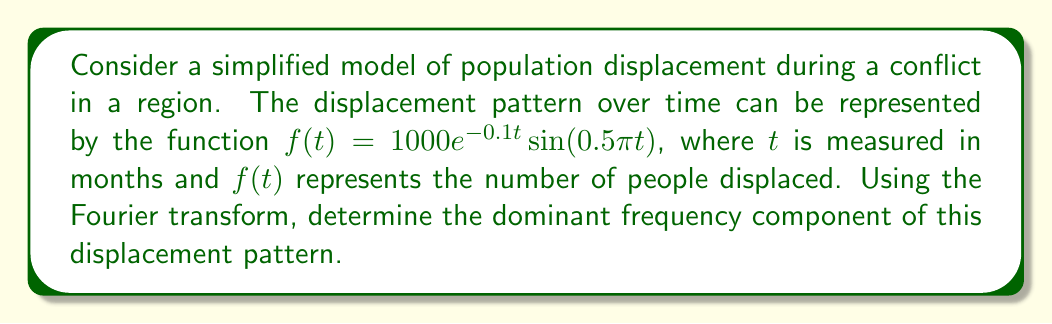What is the answer to this math problem? To solve this problem, we'll follow these steps:

1) The Fourier transform of $f(t)$ is given by:

   $$F(\omega) = \int_{-\infty}^{\infty} f(t)e^{-i\omega t}dt$$

2) In our case, $f(t) = 1000e^{-0.1t}\sin(0.5\pi t)$

3) The Fourier transform of a damped sinusoid $e^{-at}\sin(bt)$ is:

   $$\frac{b}{(a+i\omega)^2 + b^2}$$

4) In our function, $a = 0.1$ and $b = 0.5\pi$. The amplitude (1000) is a scaling factor.

5) Therefore, the Fourier transform of our function is:

   $$F(\omega) = 1000 \cdot \frac{0.5\pi}{(0.1+i\omega)^2 + (0.5\pi)^2}$$

6) To find the dominant frequency, we need to find the maximum of $|F(\omega)|$:

   $$|F(\omega)| = \frac{500\pi}{\sqrt{(0.01-\omega^2+0.25\pi^2)^2 + 0.04\omega^2}}$$

7) The maximum of this function occurs when $\omega = 0.5\pi$

8) Converting from angular frequency to regular frequency:

   $$f = \frac{\omega}{2\pi} = \frac{0.5\pi}{2\pi} = 0.25$$

This frequency is in cycles per month, as our time was measured in months.
Answer: The dominant frequency component is 0.25 cycles per month. 